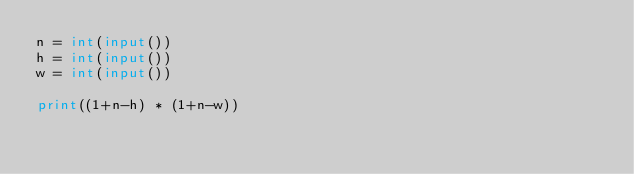<code> <loc_0><loc_0><loc_500><loc_500><_Python_>n = int(input())
h = int(input())
w = int(input())

print((1+n-h) * (1+n-w))</code> 